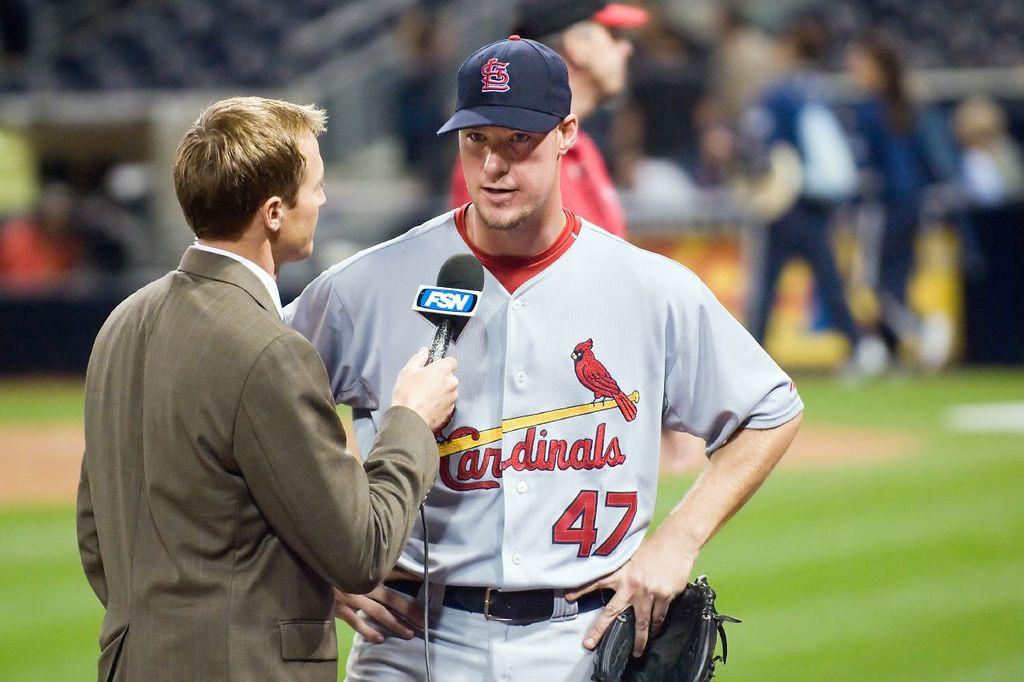What is the name of the team?
Provide a succinct answer. Cardinals. What is the player's number?
Make the answer very short. 47. 